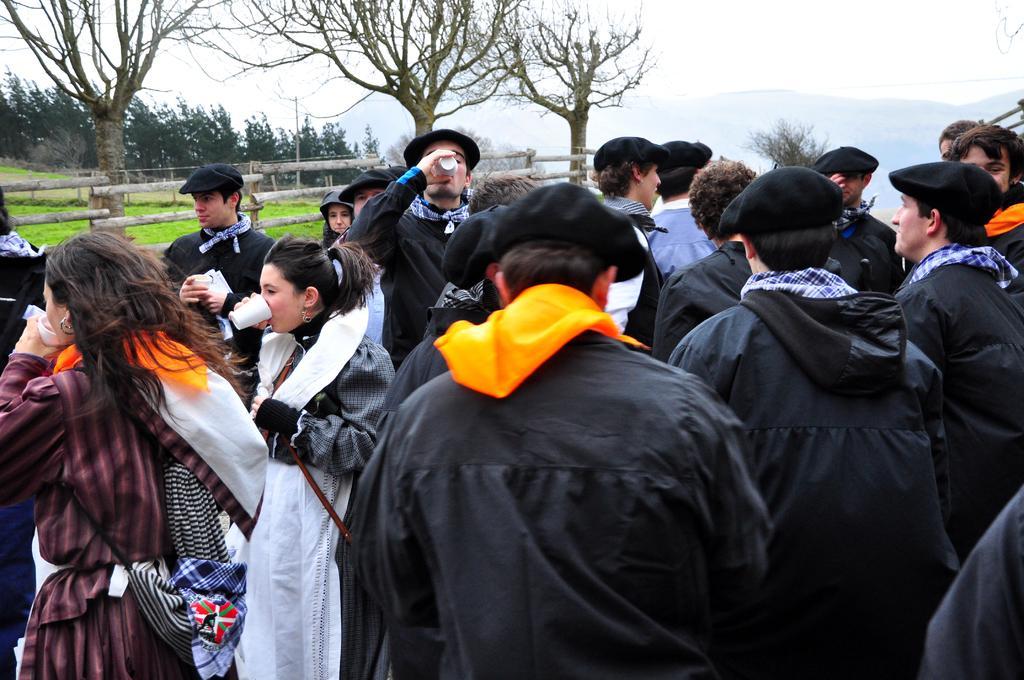Describe this image in one or two sentences. In the center of the image there are persons. In the background of the image there are trees. There is grass. There is a wooden fencing. 